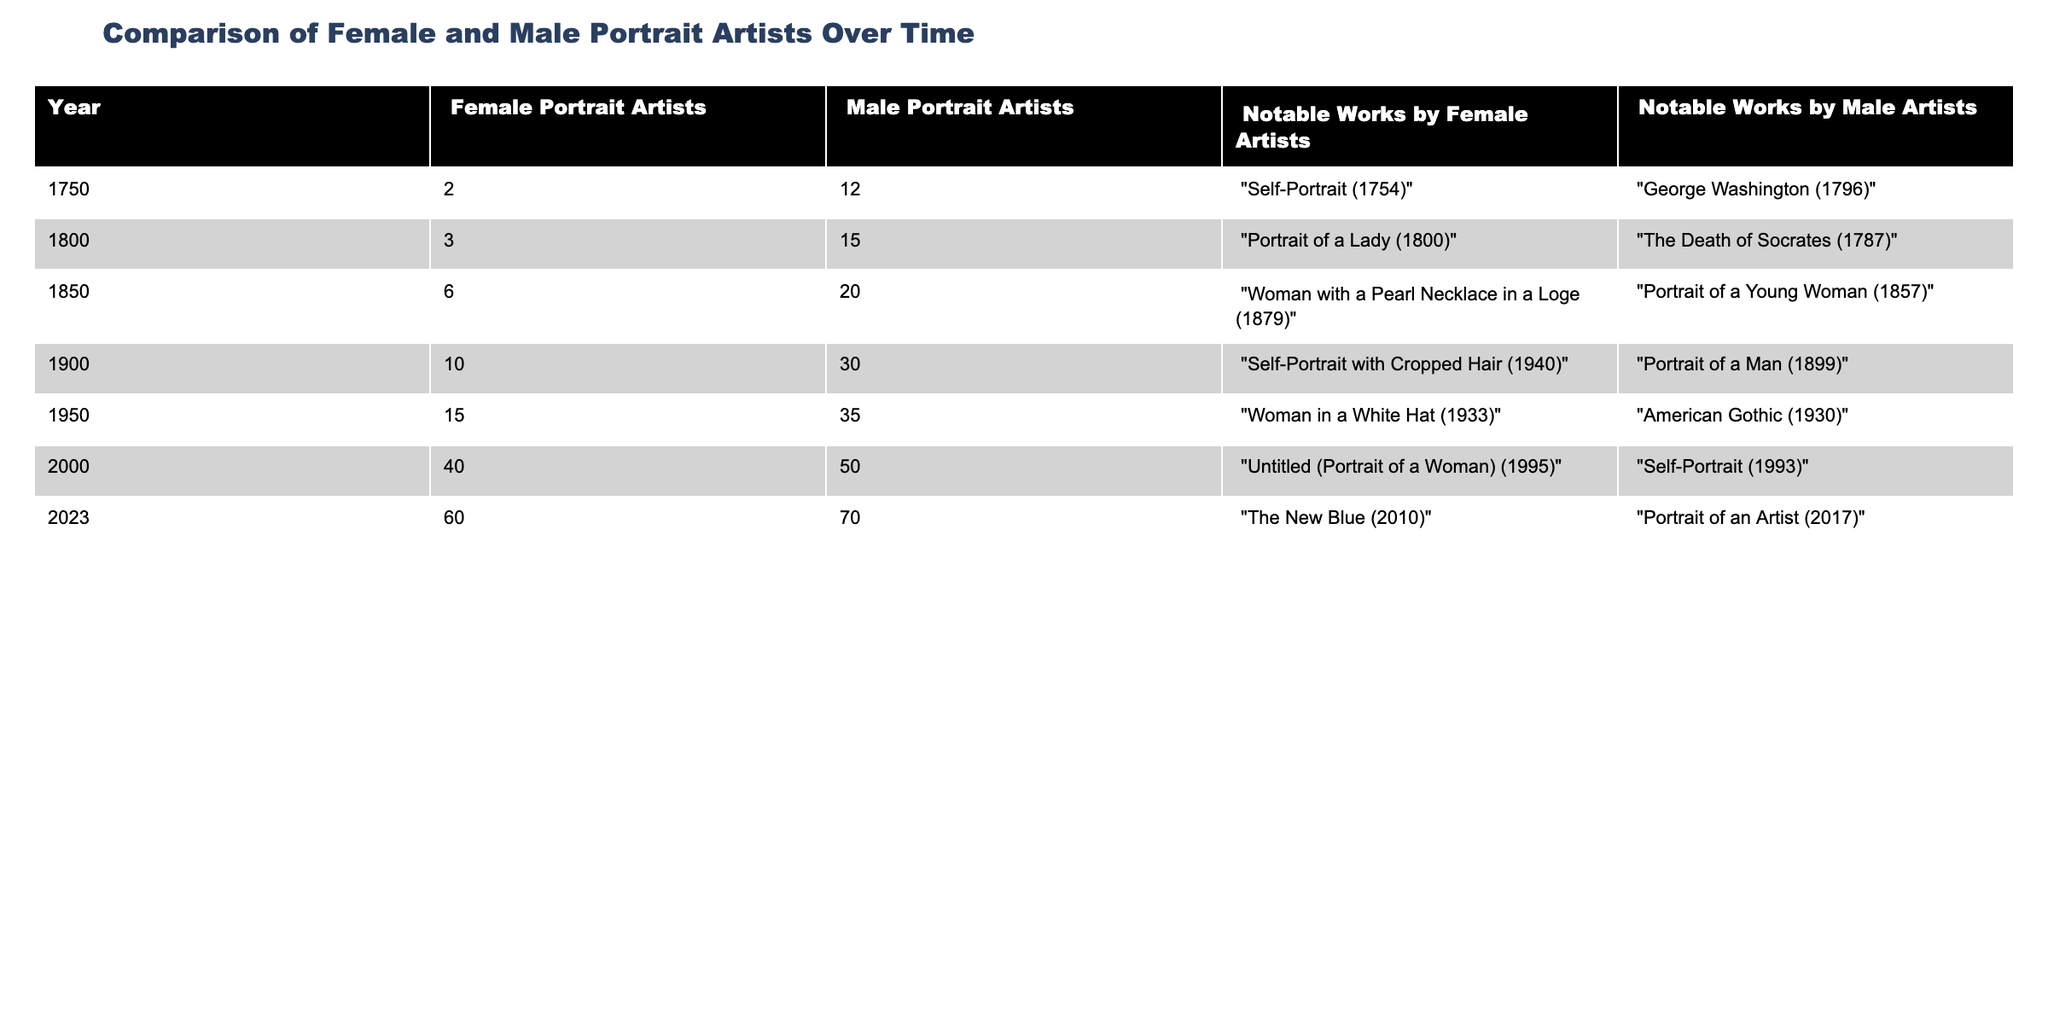What was the total number of female portrait artists in 1850? In 1850, the table lists 6 female portrait artists.
Answer: 6 What notable work did female portrait artists create in 2000? In 2000, the notable work by female artists listed in the table is "Untitled (Portrait of a Woman) (1995)".
Answer: "Untitled (Portrait of a Woman) (1995)" How many more male portrait artists were there than female portrait artists in 1950? In 1950, there were 15 female portrait artists and 35 male portrait artists. The difference is 35 - 15 = 20.
Answer: 20 What is the percentage increase in the number of female portrait artists from 1750 to 2023? In 1750, there were 2 female portrait artists, and in 2023, there were 60. The increase is 60 - 2 = 58. The percentage increase is (58/2) * 100 = 2900%.
Answer: 2900% Were there more notable works by female artists or male artists in 1900? In 1900, the notable works listed are a self-portrait by a female artist and a portrait of a man by a male artist. Both have 1 notable work each, so they are equal.
Answer: Yes, they are equal How many total notable works by male portrait artists were recorded in 1800 and 1900 combined? The notable works by male portrait artists in 1800 are 1 ("The Death of Socrates (1787)") and in 1900 are 1 ("Portrait of a Man (1899)"). Combining these gives 1 + 1 = 2.
Answer: 2 What is the average number of female portrait artists from 1750 to 2023? To find the average, add the total female artists: 2 + 3 + 6 + 10 + 15 + 40 + 60 = 136. There are 7 data points, so the average is 136 / 7 = 19.43.
Answer: 19.43 In which year did the number of female portrait artists first exceed the number of male portrait artists? In 2023, the number of female portrait artists (60) exceeded that of male artists (70), thus it did not exceed.
Answer: It has not exceeded What was the notable work by male portrait artists in 1750? In 1750, the notable work by male portrait artists is "George Washington (1796)".
Answer: "George Washington (1796)" How many total portrait artists (female and male) were there in 2000? In 2000, there were 40 female portrait artists and 50 male portrait artists. The total is 40 + 50 = 90.
Answer: 90 What trend is observed in the number of female portrait artists from 1900 to 2023? From 1900 to 2023, the number of female portrait artists increased from 10 to 60, indicating a rise in representation.
Answer: An increase 